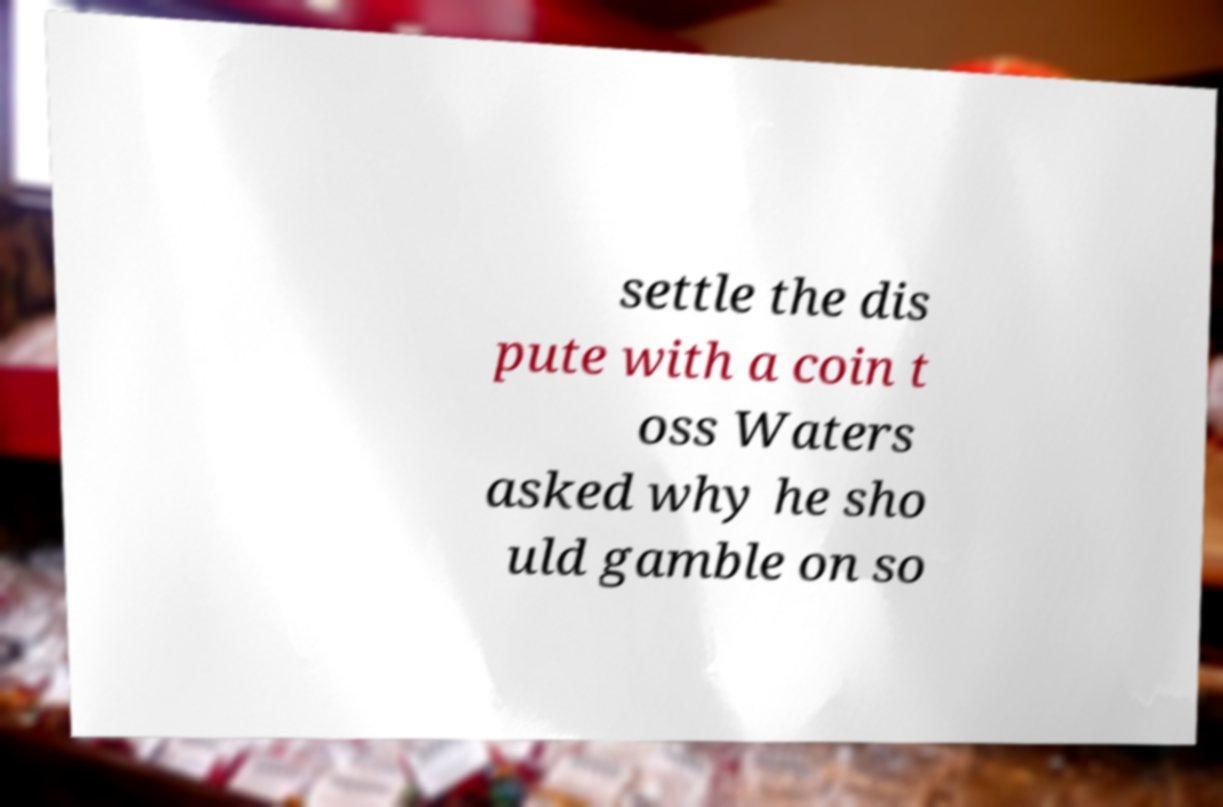I need the written content from this picture converted into text. Can you do that? settle the dis pute with a coin t oss Waters asked why he sho uld gamble on so 